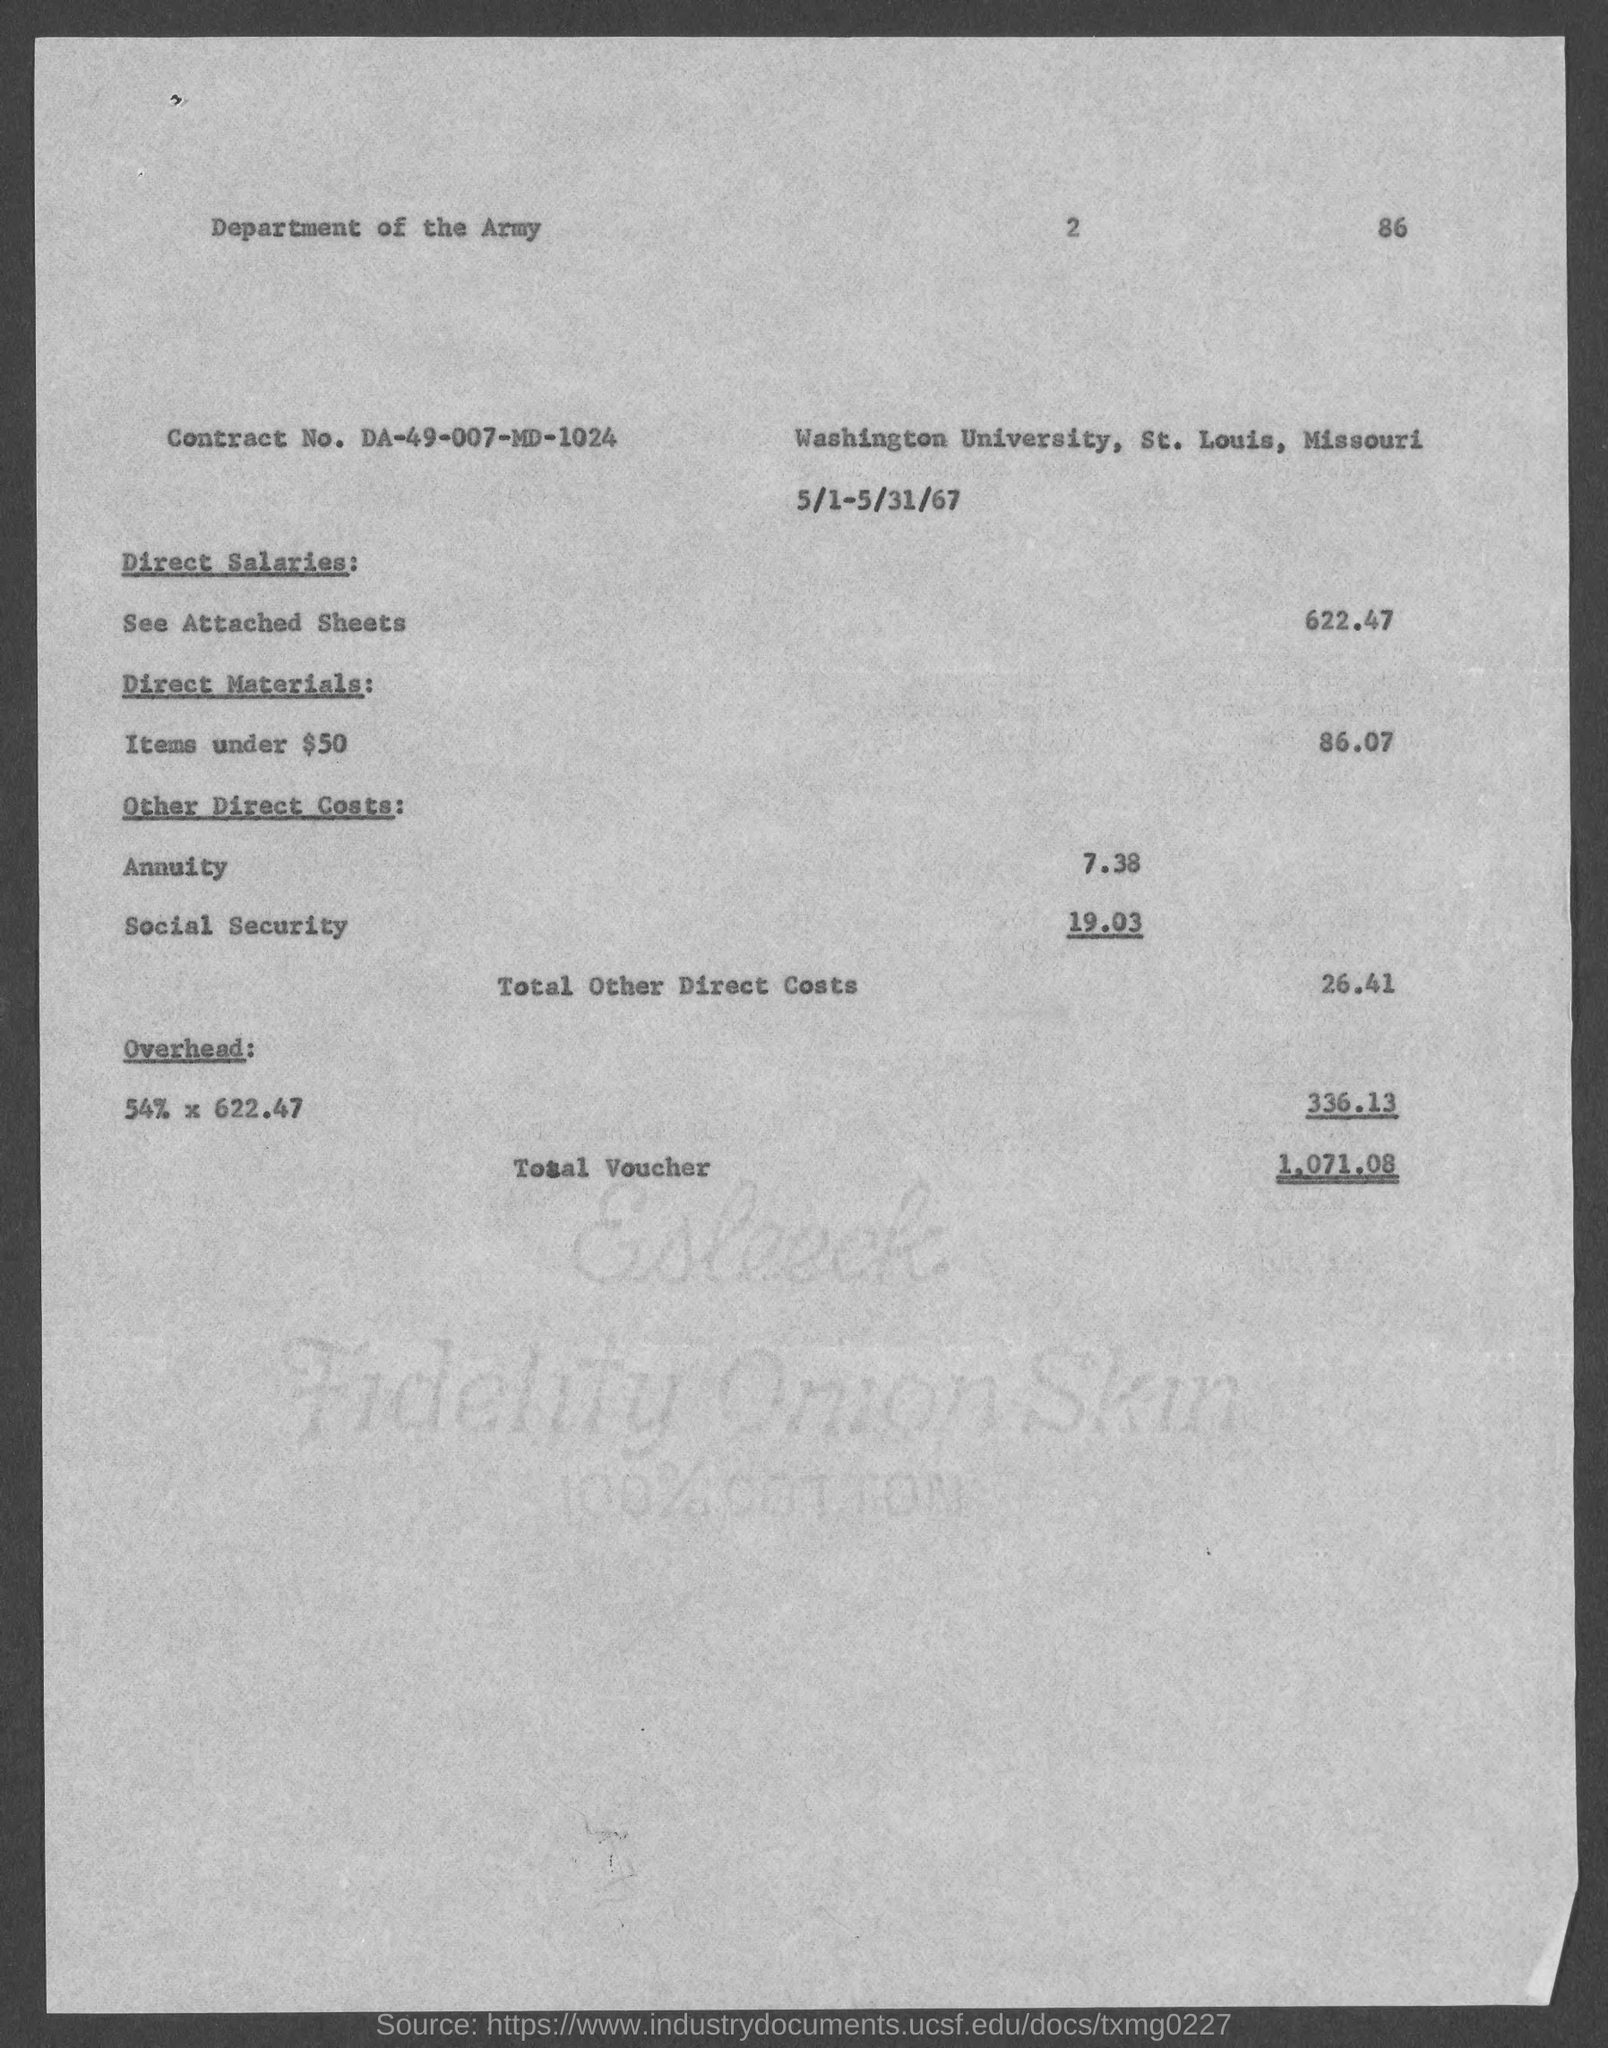What is the contract no. ?
Provide a succinct answer. DA-49-007-MD-1024. What is the total other direct costs?
Provide a short and direct response. 26.41. What is the total voucher?
Offer a very short reply. 1,071.08. What is the number at top-right corner of the page?
Your answer should be compact. 86. 